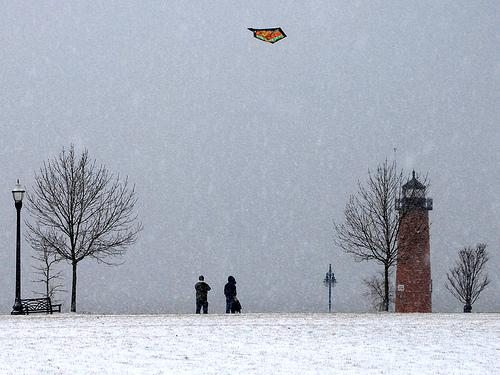Question: what is in the air?
Choices:
A. Leaves.
B. Kite.
C. Snow.
D. Balloon.
Answer with the letter. Answer: B Question: where is this location?
Choices:
A. Harbor.
B. Landfill.
C. Construction site.
D. Park.
Answer with the letter. Answer: D Question: how many people can be seen?
Choices:
A. Four.
B. Three.
C. Five.
D. Six.
Answer with the letter. Answer: B Question: why is the kite in the air?
Choices:
A. Boy dropped string.
B. Boy is running with it.
C. Kite festival.
D. Wind.
Answer with the letter. Answer: D Question: who is holding the kite?
Choices:
A. Woman.
B. Little boy.
C. Man.
D. Teenage girl.
Answer with the letter. Answer: C Question: when was the picture taken?
Choices:
A. Daytime.
B. Evening.
C. Morning.
D. 11:50.
Answer with the letter. Answer: B 